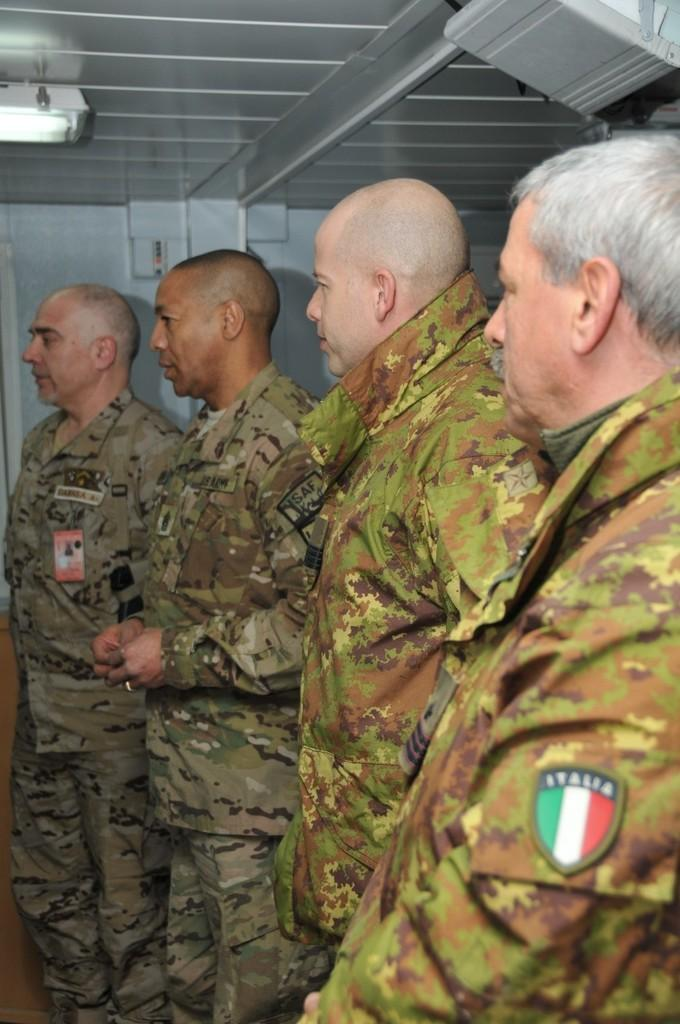How many people are in the image? There are 4 men in the image. What are the men wearing? The men are wearing military uniforms. Can you describe any additional features in the image? There is a light on the top of the image. What type of action is the frog performing in the image? There is no frog present in the image, so it is not possible to answer that question. 